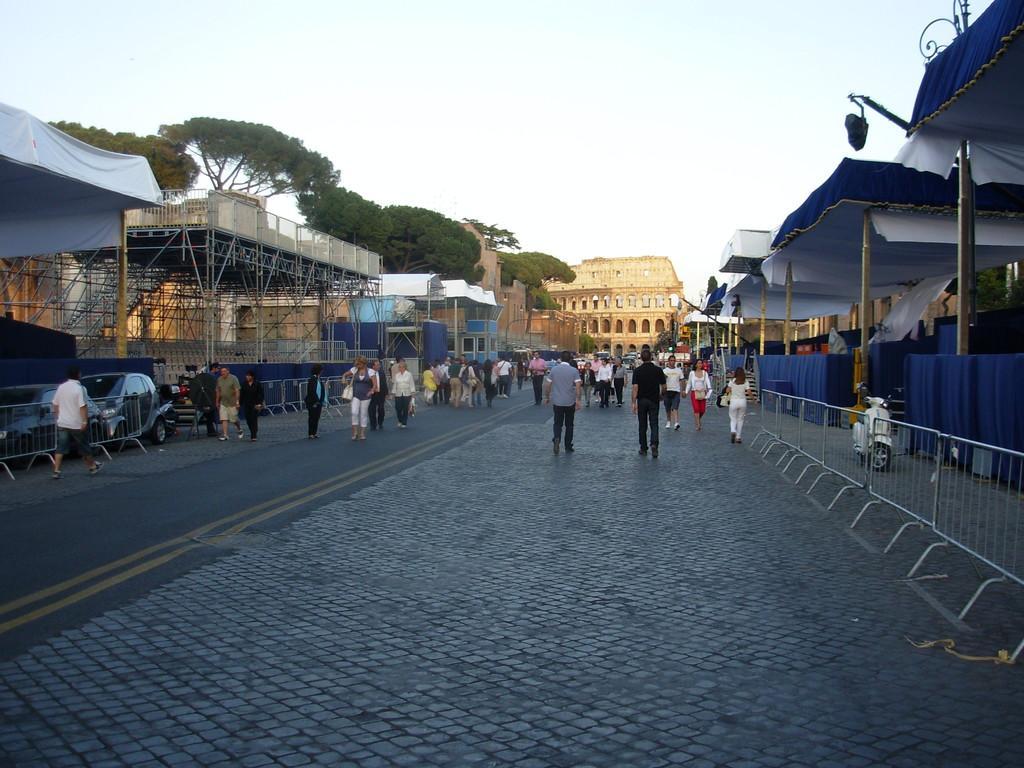In one or two sentences, can you explain what this image depicts? In this picture we can see people and vehicles on the road, here we can see fences, buildings, tents, trees and some objects and we can see sky in the background. 